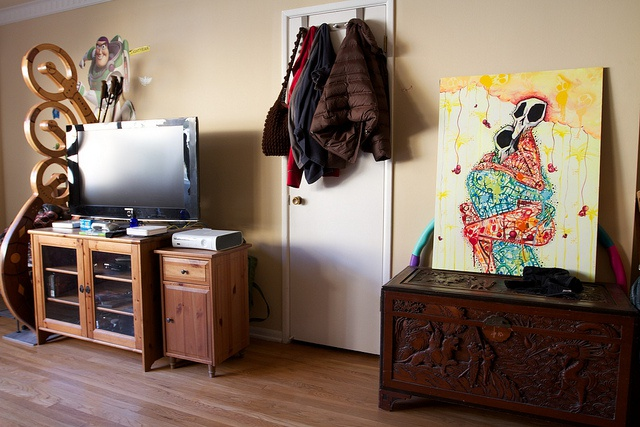Describe the objects in this image and their specific colors. I can see tv in gray, white, black, and darkgray tones, handbag in gray, black, ivory, darkgray, and maroon tones, book in gray, lightgray, and darkgray tones, book in gray, white, and darkgray tones, and remote in gray and black tones in this image. 